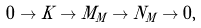<formula> <loc_0><loc_0><loc_500><loc_500>0 \to K \to M _ { M } \to N _ { M } \to 0 ,</formula> 